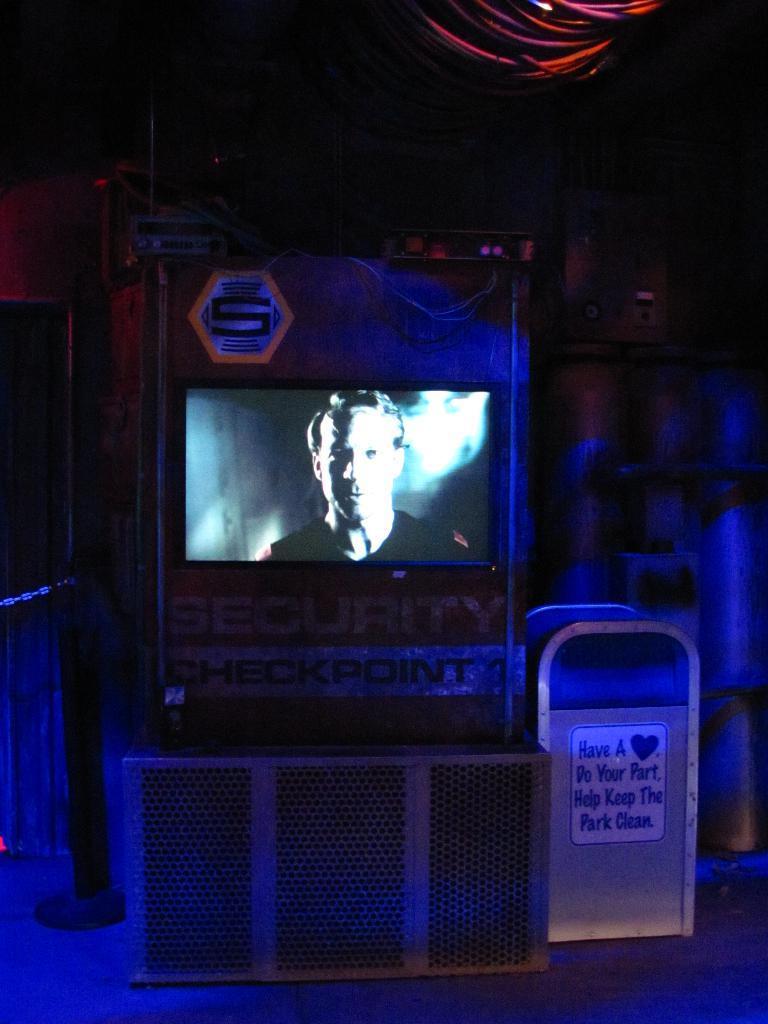Please provide a concise description of this image. In this image in the center there is a screen and on the screen there is a man. On the top of the screen there is a symbol. On the right side of the screen there is a stand with some text written on it. 